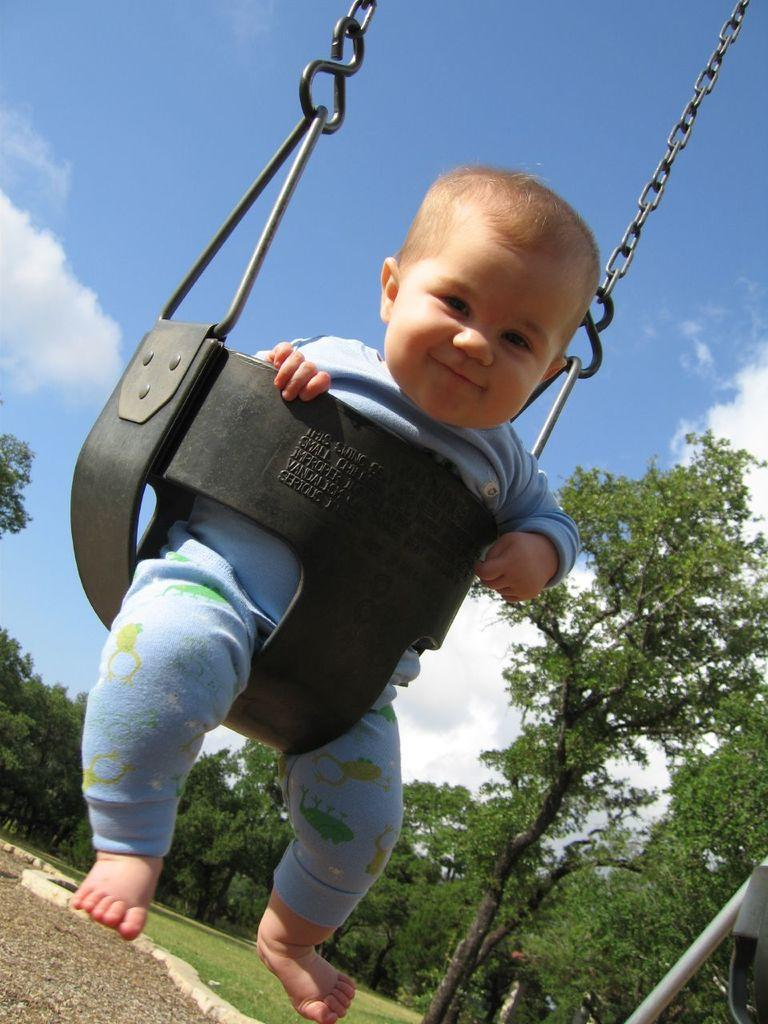What is the main subject in the image? There is a baby in the swing. What can be seen on the right side of the image? There are trees on the right side of the image. How many dogs are present in the image? There are no dogs present in the image. Can you describe the icicle hanging from the baby's swing? There is no icicle present in the image; it is a baby in a swing with trees on the right side. 